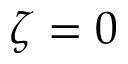<formula> <loc_0><loc_0><loc_500><loc_500>\zeta = 0</formula> 